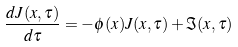Convert formula to latex. <formula><loc_0><loc_0><loc_500><loc_500>\frac { d J ( x , \tau ) } { d \tau } = - \phi ( x ) J ( x , \tau ) + \Im ( x , \tau )</formula> 